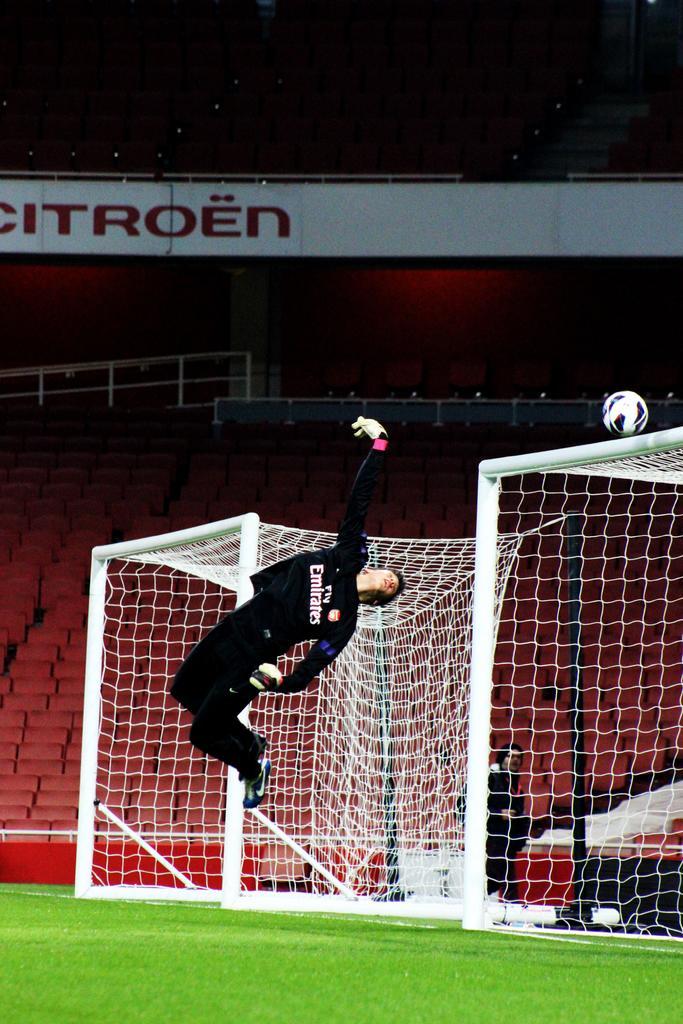How would you summarize this image in a sentence or two? In this picture I can observe a man in the middle of the picture. I can observe two goal posts in this picture. On the right side I can observe football. In the background there is a stadium. 